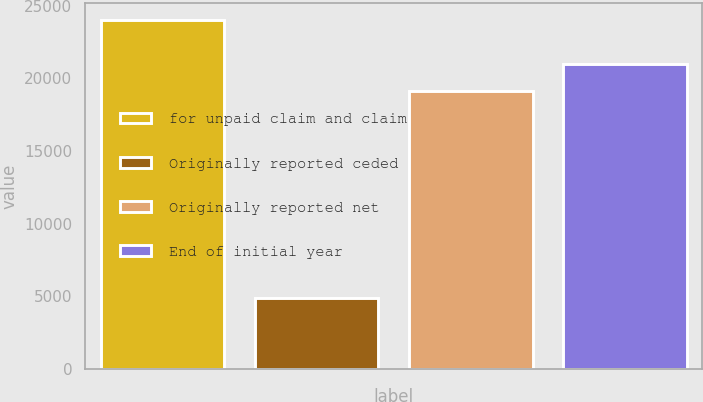<chart> <loc_0><loc_0><loc_500><loc_500><bar_chart><fcel>for unpaid claim and claim<fcel>Originally reported ceded<fcel>Originally reported net<fcel>End of initial year<nl><fcel>24015<fcel>4911<fcel>19104<fcel>21014.4<nl></chart> 